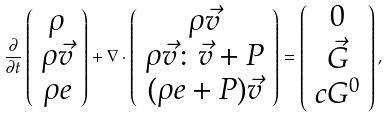<formula> <loc_0><loc_0><loc_500><loc_500>\frac { \partial } { \partial t } \left ( \begin{array} { c } \rho \\ \rho \vec { v } \\ \rho e \end{array} \right ) + \nabla \cdot \left ( \begin{array} { c } \rho \vec { v } \\ \rho \vec { v } \colon \vec { v } + P \\ ( \rho e + P ) \vec { v } \end{array} \right ) = \left ( \begin{array} { c } 0 \\ \vec { G } \\ c G ^ { 0 } \end{array} \right ) ,</formula> 